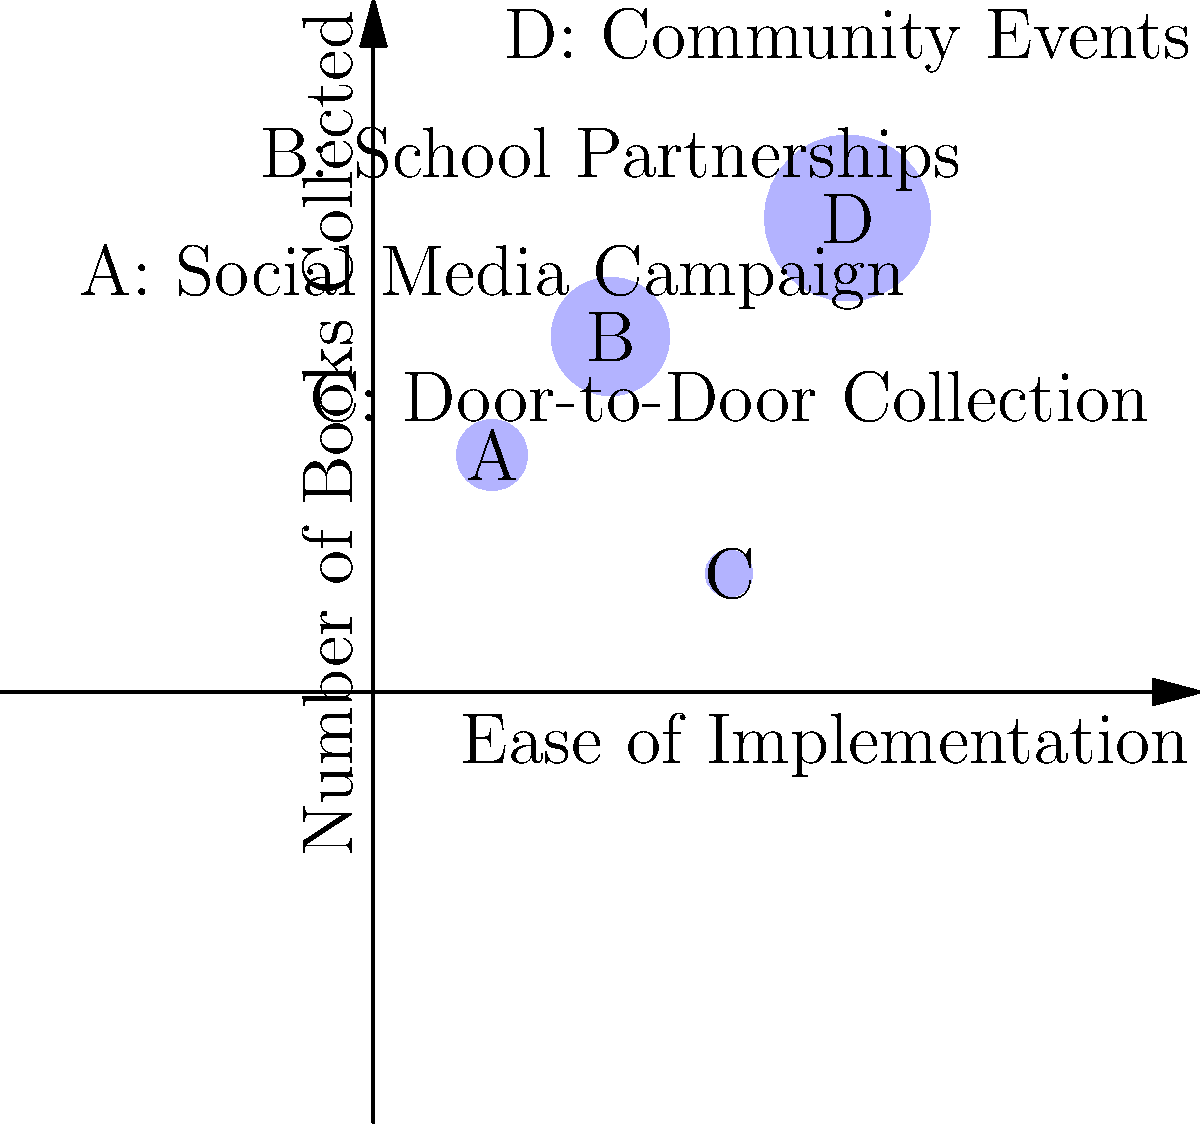Based on the bubble chart comparing different book collection methods for a community book donation drive, which method appears to be the most effective in terms of both ease of implementation and number of books collected? Explain your reasoning, considering the trade-offs between these two factors. To determine the most effective book collection method, we need to analyze both the ease of implementation (x-axis) and the number of books collected (y-axis) for each method. The size of each bubble represents a third factor, which could be interpreted as the overall effectiveness or resource requirement.

Let's examine each method:

1. Method A (Social Media Campaign):
   - Ease of implementation: Low (x = 1)
   - Number of books collected: Moderate (y = 2)
   - Overall effectiveness: Moderate (medium-sized bubble)

2. Method B (School Partnerships):
   - Ease of implementation: Moderate (x = 2)
   - Number of books collected: High (y = 3)
   - Overall effectiveness: High (large bubble)

3. Method C (Door-to-Door Collection):
   - Ease of implementation: High (x = 3)
   - Number of books collected: Low (y = 1)
   - Overall effectiveness: Low (small bubble)

4. Method D (Community Events):
   - Ease of implementation: Very High (x = 4)
   - Number of books collected: Very High (y = 4)
   - Overall effectiveness: Very High (largest bubble)

Considering the trade-offs:
- Method A is easy to implement but yields moderate results.
- Method B offers a good balance between ease and effectiveness.
- Method C is relatively easy to implement but yields poor results.
- Method D excels in both ease of implementation and number of books collected.

Based on this analysis, Method D (Community Events) appears to be the most effective. It has the highest score in both ease of implementation and number of books collected, as well as the largest bubble size, indicating the highest overall effectiveness.
Answer: Method D (Community Events) is the most effective, balancing ease of implementation and number of books collected while showing the highest overall effectiveness. 